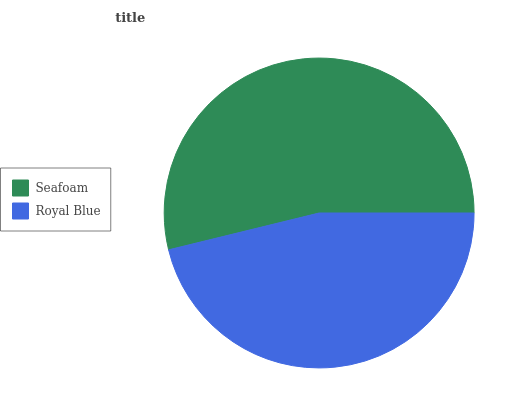Is Royal Blue the minimum?
Answer yes or no. Yes. Is Seafoam the maximum?
Answer yes or no. Yes. Is Royal Blue the maximum?
Answer yes or no. No. Is Seafoam greater than Royal Blue?
Answer yes or no. Yes. Is Royal Blue less than Seafoam?
Answer yes or no. Yes. Is Royal Blue greater than Seafoam?
Answer yes or no. No. Is Seafoam less than Royal Blue?
Answer yes or no. No. Is Seafoam the high median?
Answer yes or no. Yes. Is Royal Blue the low median?
Answer yes or no. Yes. Is Royal Blue the high median?
Answer yes or no. No. Is Seafoam the low median?
Answer yes or no. No. 